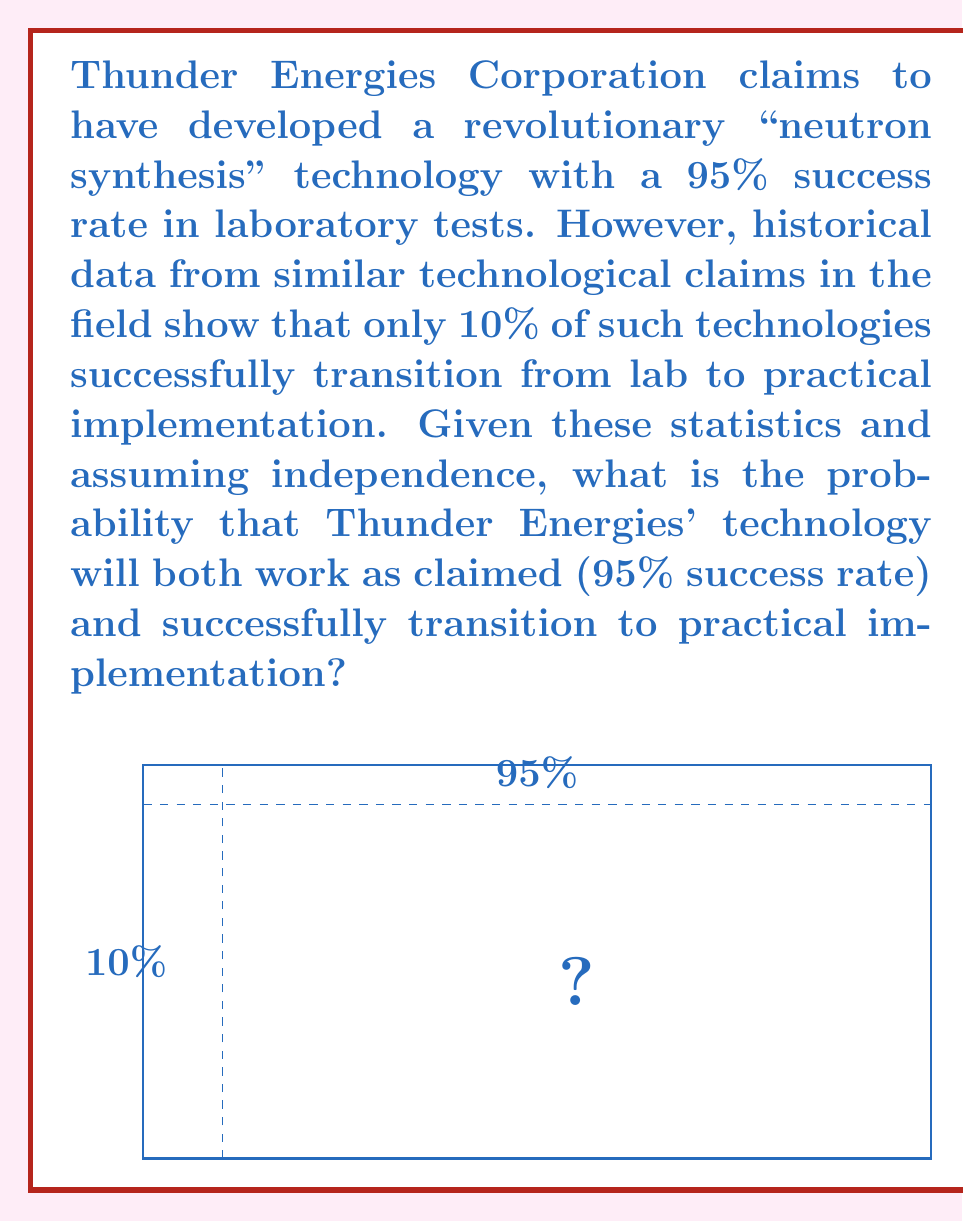Could you help me with this problem? To solve this problem, we need to consider two independent events:

1. The technology works as claimed (95% success rate)
2. The technology successfully transitions to practical implementation (10% historical success rate)

We need to calculate the probability of both events occurring together. Since these events are independent, we can multiply their individual probabilities:

Let A = event that the technology works as claimed
Let B = event that the technology successfully transitions to practical implementation

$$P(A \text{ and } B) = P(A) \times P(B)$$

Given:
$$P(A) = 0.95$$
$$P(B) = 0.10$$

Calculating:
$$P(A \text{ and } B) = 0.95 \times 0.10 = 0.095$$

To express this as a percentage:
$$0.095 \times 100\% = 9.5\%$$

This result suggests that despite the claimed high success rate in laboratory tests, the overall probability of the technology both working as claimed and successfully transitioning to practical implementation is relatively low, at 9.5%.
Answer: 9.5% 